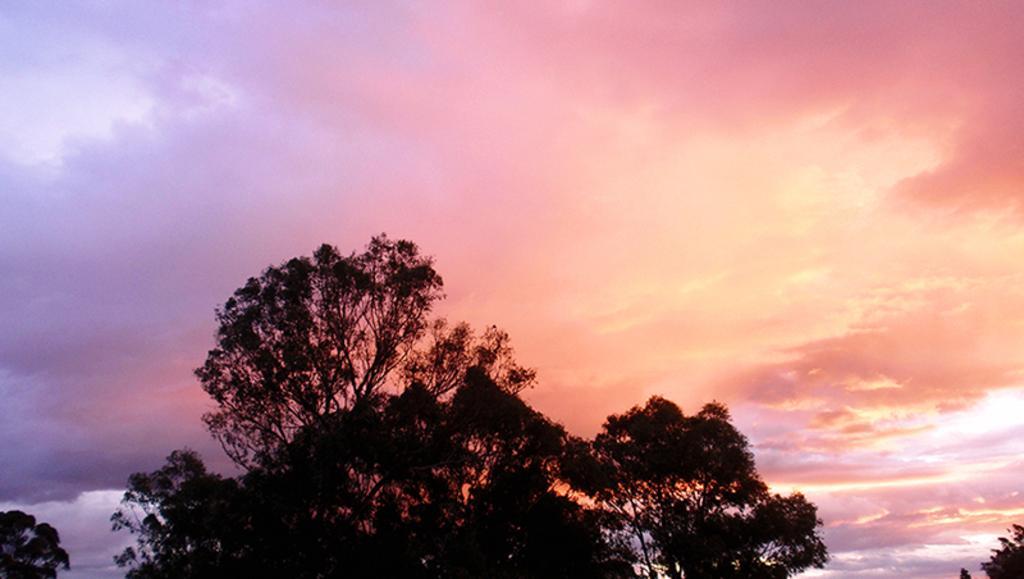Describe this image in one or two sentences. At the bottom of this image I can see some trees. On the top of the image I can see the sky and clouds. 